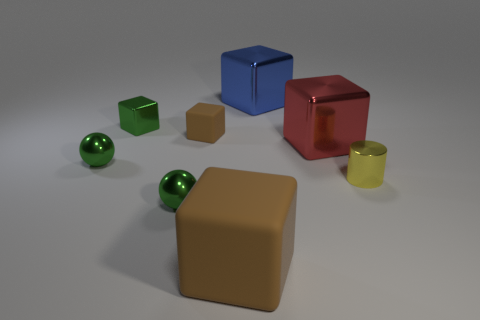Subtract all blue cubes. How many cubes are left? 4 Subtract all tiny metallic cubes. How many cubes are left? 4 Subtract 3 cubes. How many cubes are left? 2 Subtract all cyan blocks. Subtract all purple balls. How many blocks are left? 5 Add 1 small blue cylinders. How many objects exist? 9 Subtract all cylinders. How many objects are left? 7 Subtract all big purple things. Subtract all tiny matte cubes. How many objects are left? 7 Add 5 small things. How many small things are left? 10 Add 3 red shiny things. How many red shiny things exist? 4 Subtract 0 brown cylinders. How many objects are left? 8 